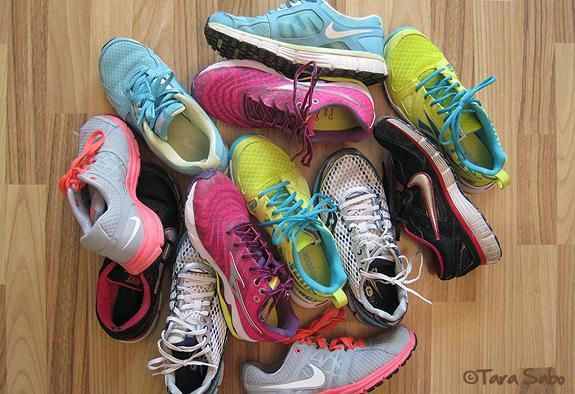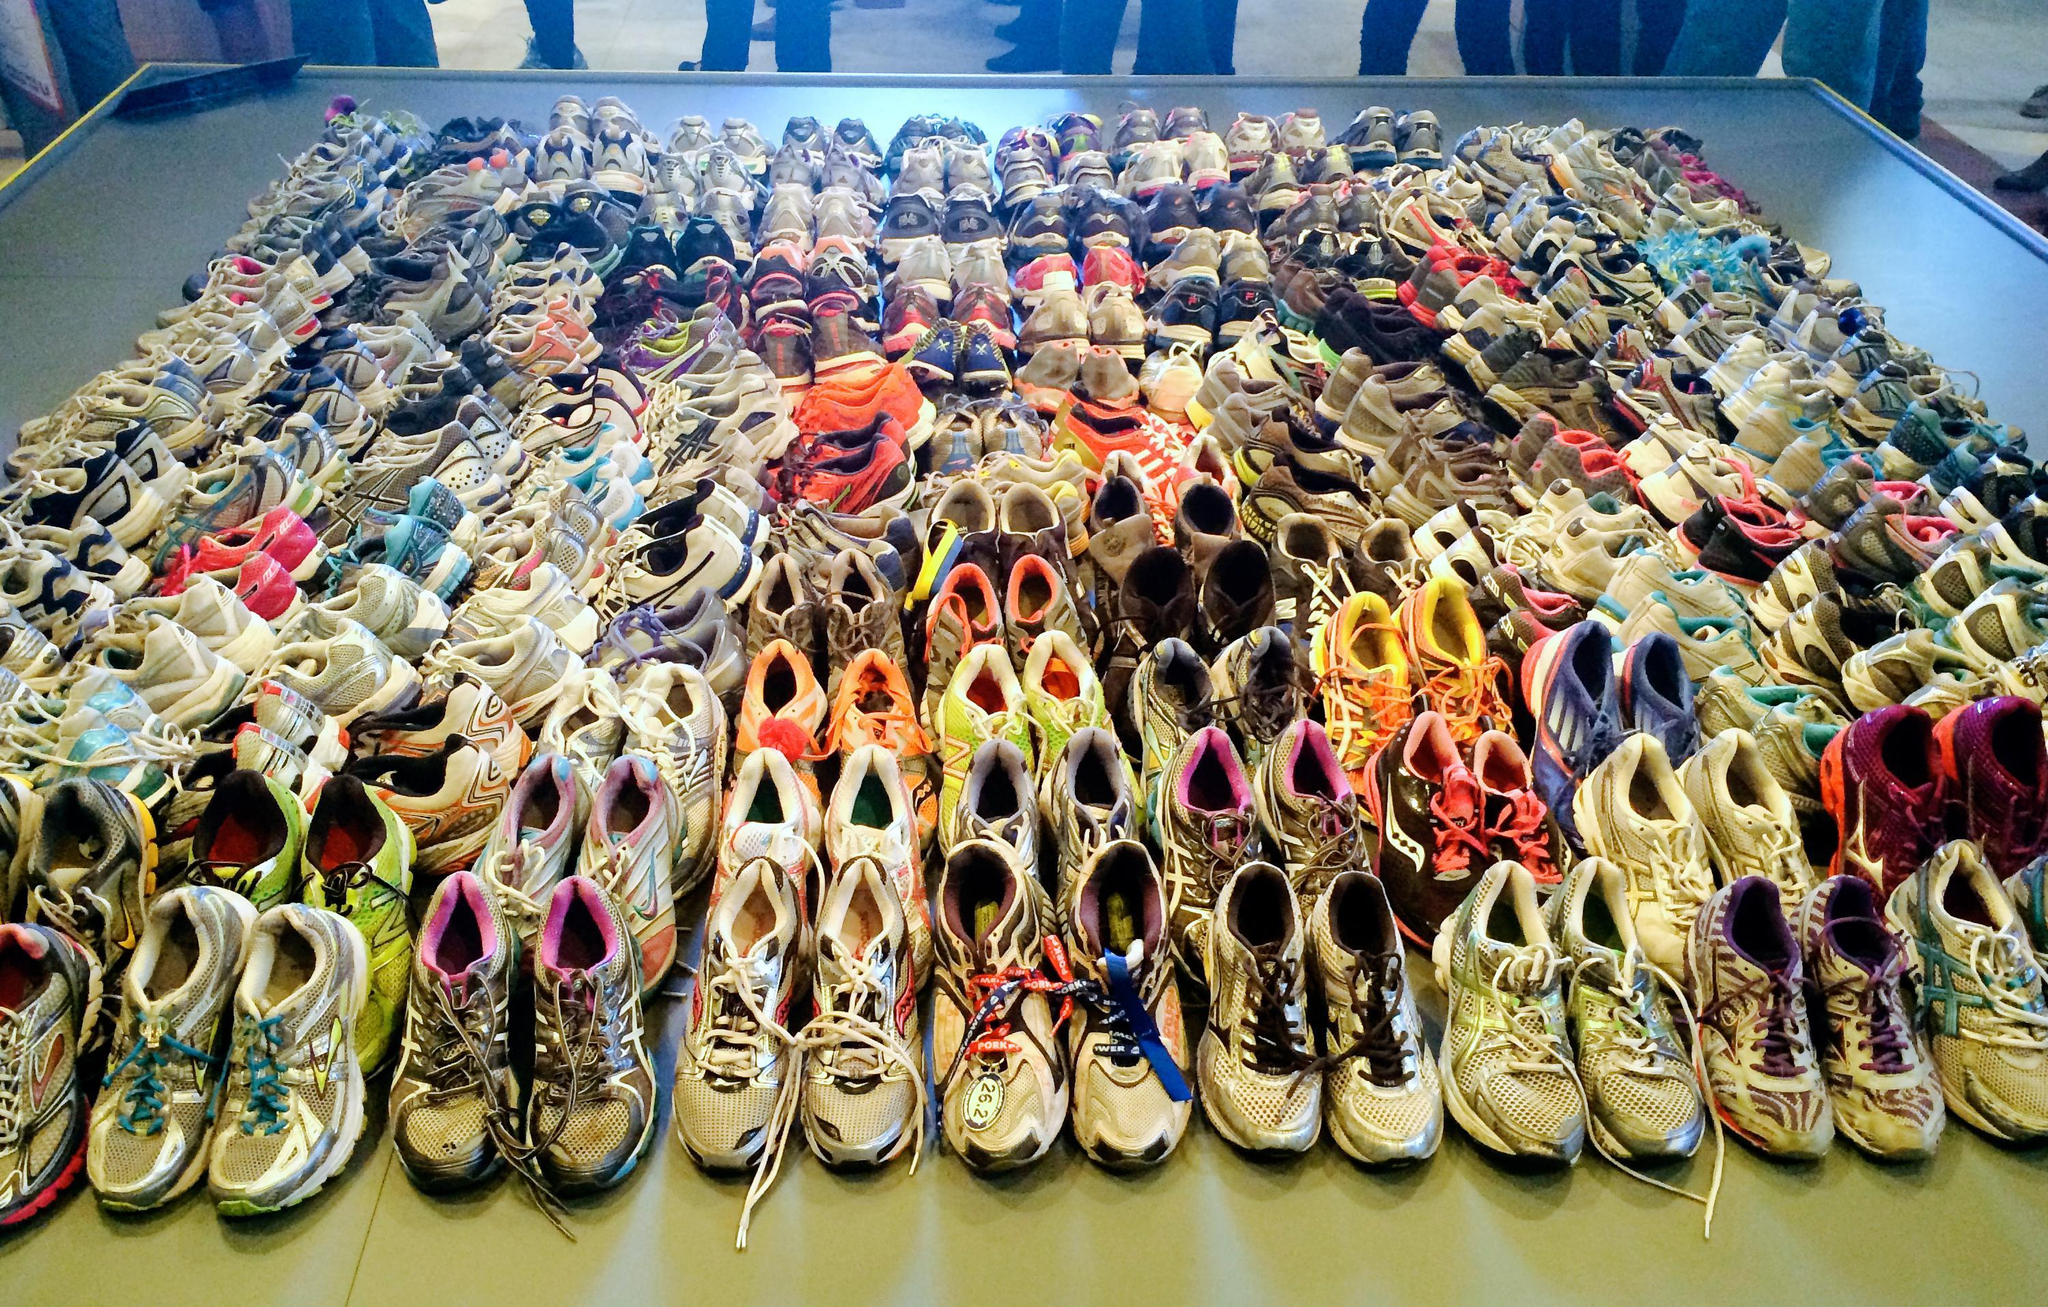The first image is the image on the left, the second image is the image on the right. For the images displayed, is the sentence "There is a triangular pile of shoes in the image on the right." factually correct? Answer yes or no. No. The first image is the image on the left, the second image is the image on the right. Given the left and right images, does the statement "The shoes in one of the pictures are not piled up on each other." hold true? Answer yes or no. Yes. 